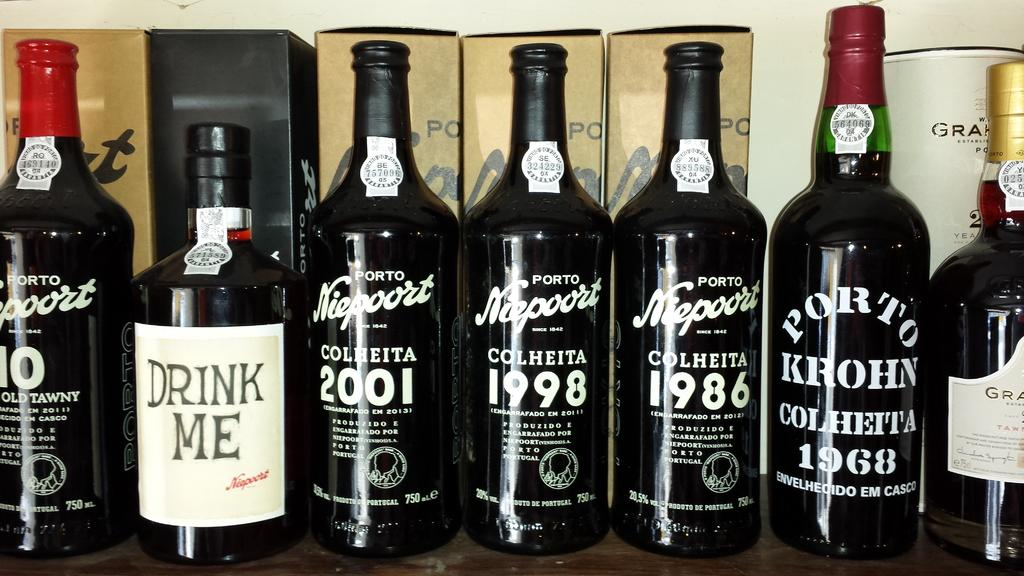<image>
Summarize the visual content of the image. Bottles of liquor with white lettering and one reads "Drink Me" 